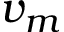Convert formula to latex. <formula><loc_0><loc_0><loc_500><loc_500>v _ { m }</formula> 